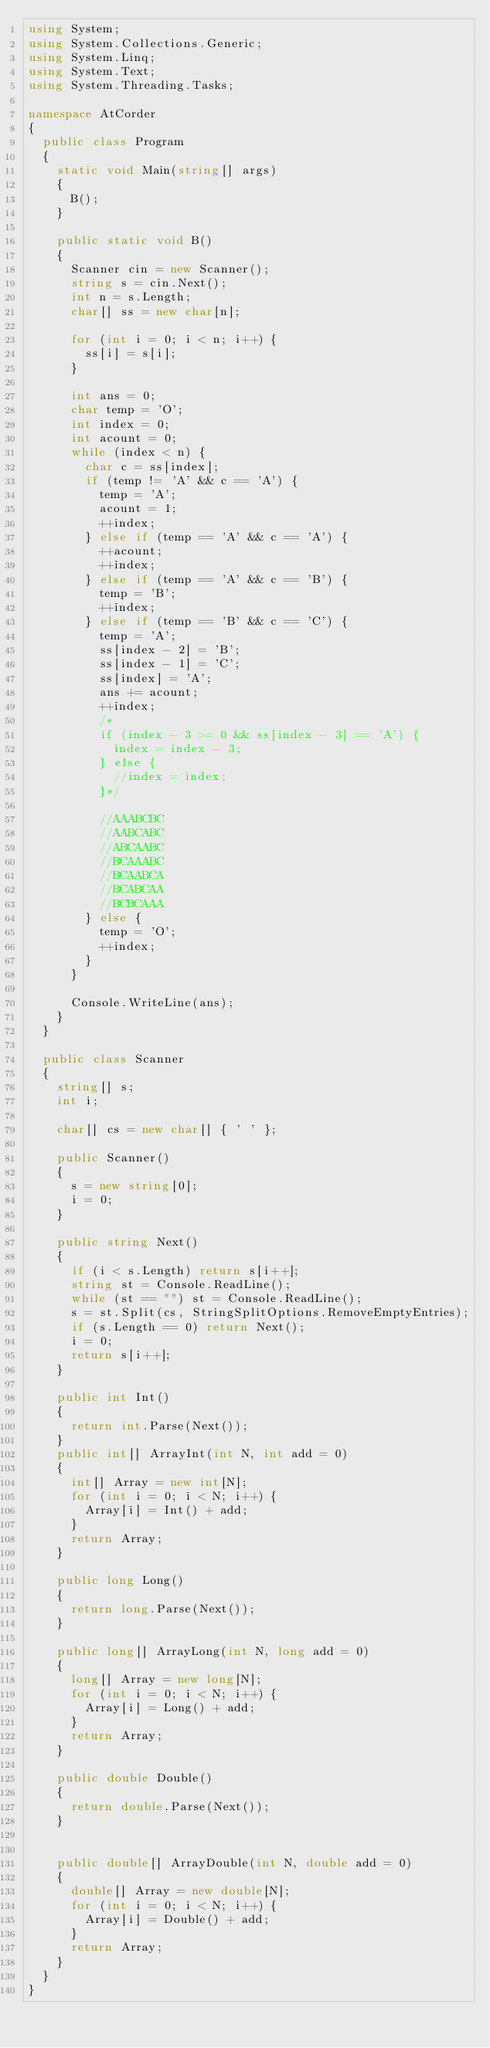Convert code to text. <code><loc_0><loc_0><loc_500><loc_500><_C#_>using System;
using System.Collections.Generic;
using System.Linq;
using System.Text;
using System.Threading.Tasks;

namespace AtCorder
{
	public class Program
	{
		static void Main(string[] args)
		{
			B();
		}

		public static void B()
		{
			Scanner cin = new Scanner();
			string s = cin.Next();
			int n = s.Length;
			char[] ss = new char[n];
			
			for (int i = 0; i < n; i++) {
				ss[i] = s[i];
			}

			int ans = 0;
			char temp = 'O';
			int index = 0;
			int acount = 0;
			while (index < n) {
				char c = ss[index];
				if (temp != 'A' && c == 'A') {
					temp = 'A';
					acount = 1;
					++index;
				} else if (temp == 'A' && c == 'A') {
					++acount;
					++index;
				} else if (temp == 'A' && c == 'B') {
					temp = 'B';
					++index;
				} else if (temp == 'B' && c == 'C') {
					temp = 'A';
					ss[index - 2] = 'B';
					ss[index - 1] = 'C';
					ss[index] = 'A';
					ans += acount;
					++index;
					/*
					if (index - 3 >= 0 && ss[index - 3] == 'A') {
						index = index - 3;
					} else {
						//index = index;
					}*/

					//AAABCBC
					//AABCABC
					//ABCAABC
					//BCAAABC
					//BCAABCA
					//BCABCAA
					//BCBCAAA
				} else {
					temp = 'O';
					++index;
				}
			}

			Console.WriteLine(ans);
		}
	}

	public class Scanner
	{
		string[] s;
		int i;

		char[] cs = new char[] { ' ' };

		public Scanner()
		{
			s = new string[0];
			i = 0;
		}

		public string Next()
		{
			if (i < s.Length) return s[i++];
			string st = Console.ReadLine();
			while (st == "") st = Console.ReadLine();
			s = st.Split(cs, StringSplitOptions.RemoveEmptyEntries);
			if (s.Length == 0) return Next();
			i = 0;
			return s[i++];
		}

		public int Int()
		{
			return int.Parse(Next());
		}
		public int[] ArrayInt(int N, int add = 0)
		{
			int[] Array = new int[N];
			for (int i = 0; i < N; i++) {
				Array[i] = Int() + add;
			}
			return Array;
		}

		public long Long()
		{
			return long.Parse(Next());
		}

		public long[] ArrayLong(int N, long add = 0)
		{
			long[] Array = new long[N];
			for (int i = 0; i < N; i++) {
				Array[i] = Long() + add;
			}
			return Array;
		}

		public double Double()
		{
			return double.Parse(Next());
		}


		public double[] ArrayDouble(int N, double add = 0)
		{
			double[] Array = new double[N];
			for (int i = 0; i < N; i++) {
				Array[i] = Double() + add;
			}
			return Array;
		}
	}
}
</code> 